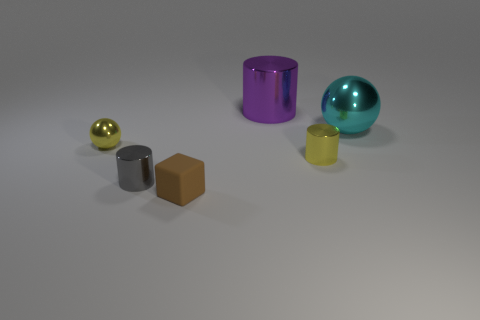Add 3 metallic spheres. How many objects exist? 9 Subtract all balls. How many objects are left? 4 Subtract all large shiny blocks. Subtract all large objects. How many objects are left? 4 Add 3 spheres. How many spheres are left? 5 Add 1 tiny brown rubber blocks. How many tiny brown rubber blocks exist? 2 Subtract 0 green balls. How many objects are left? 6 